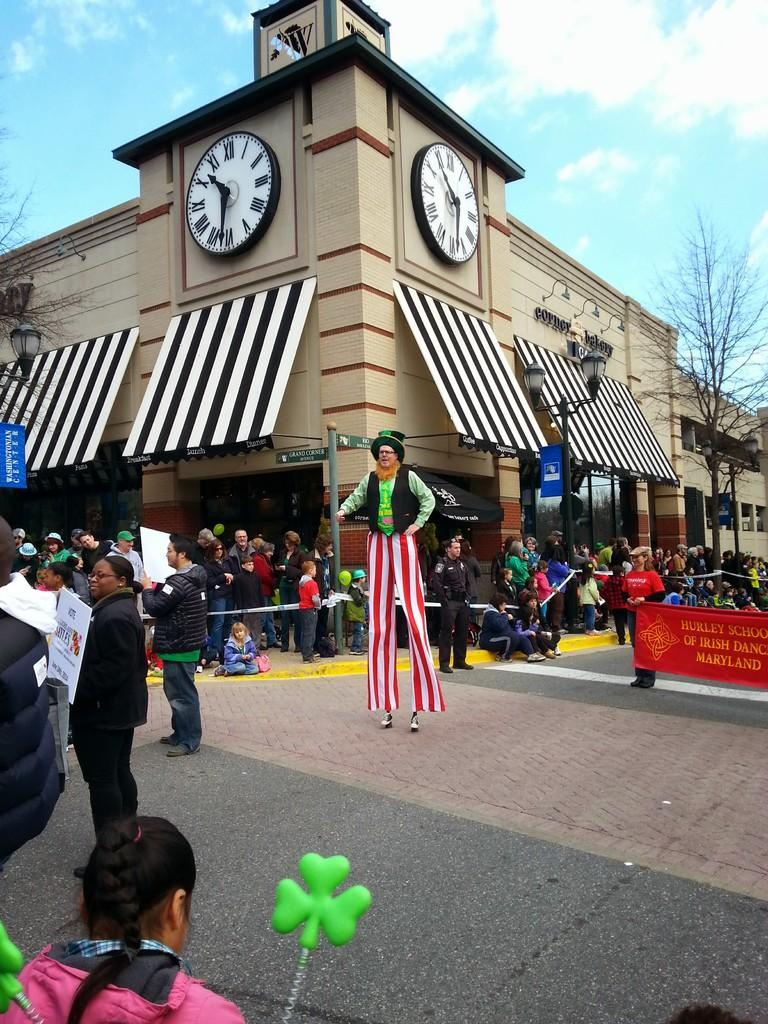<image>
Relay a brief, clear account of the picture shown. An outside event that is featuring the Hurley School out of Maryland. 